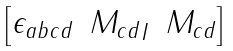<formula> <loc_0><loc_0><loc_500><loc_500>\begin{bmatrix} \epsilon _ { a b c d } & { M _ { c d } } _ { I } & { M _ { c d } } \\ \end{bmatrix}</formula> 